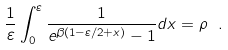<formula> <loc_0><loc_0><loc_500><loc_500>\frac { 1 } { \varepsilon } \int _ { 0 } ^ { \varepsilon } \frac { 1 } { e ^ { \beta ( 1 - \varepsilon / 2 + x ) } - 1 } d x = \rho \ .</formula> 